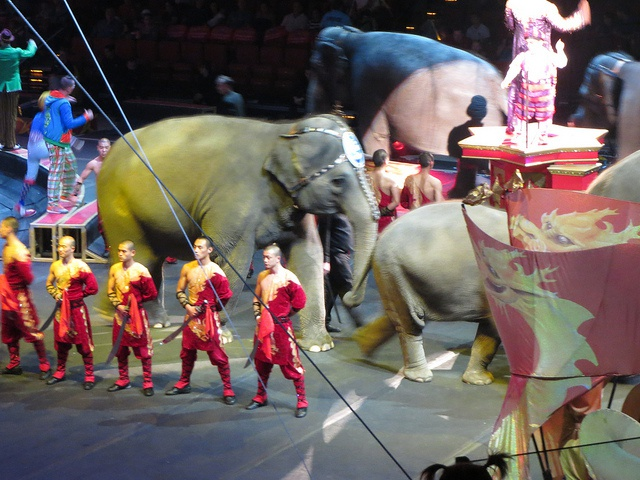Describe the objects in this image and their specific colors. I can see elephant in black, olive, gray, and darkgray tones, elephant in black, lightgray, pink, and darkgray tones, elephant in black, darkgray, gray, lightgray, and olive tones, people in black, brown, maroon, and white tones, and people in black, maroon, brown, and gray tones in this image. 